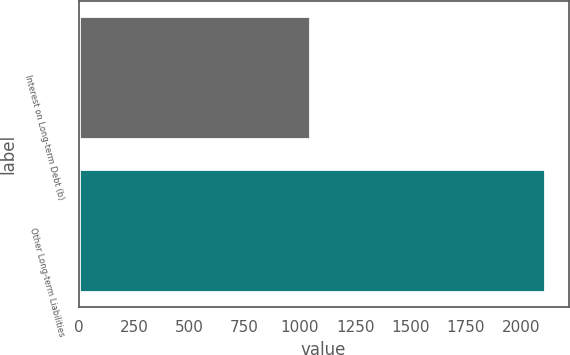Convert chart. <chart><loc_0><loc_0><loc_500><loc_500><bar_chart><fcel>Interest on Long-term Debt (b)<fcel>Other Long-term Liabilities<nl><fcel>1045<fcel>2109<nl></chart> 